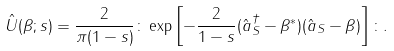<formula> <loc_0><loc_0><loc_500><loc_500>\hat { U } ( \beta ; s ) = \frac { 2 } { \pi ( 1 - s ) } \colon \exp \left [ - \frac { 2 } { 1 - s } ( \hat { a } _ { S } ^ { \dagger } - \beta ^ { \ast } ) ( \hat { a } _ { S } - \beta ) \right ] \colon .</formula> 